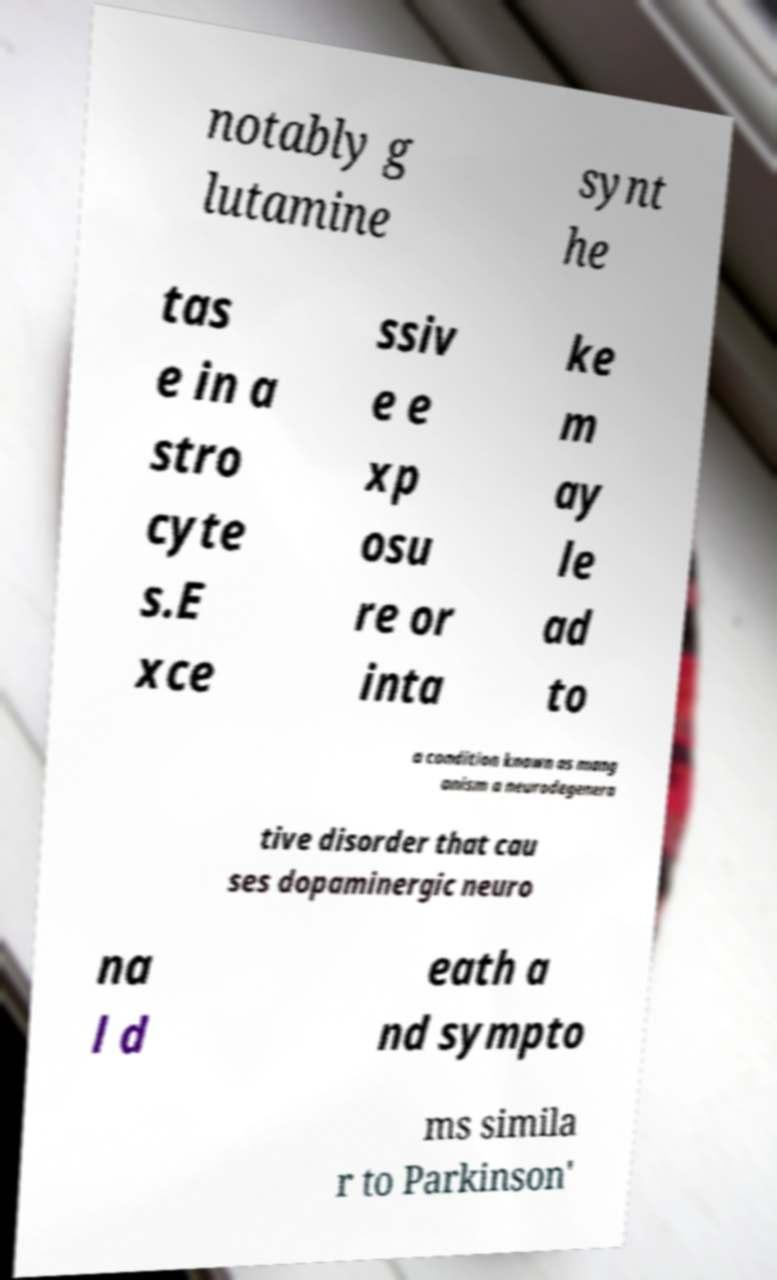Can you accurately transcribe the text from the provided image for me? notably g lutamine synt he tas e in a stro cyte s.E xce ssiv e e xp osu re or inta ke m ay le ad to a condition known as mang anism a neurodegenera tive disorder that cau ses dopaminergic neuro na l d eath a nd sympto ms simila r to Parkinson' 